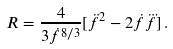Convert formula to latex. <formula><loc_0><loc_0><loc_500><loc_500>R = \frac { 4 } { 3 \dot { f } ^ { 8 / 3 } } [ \ddot { f } ^ { 2 } - 2 \dot { f } \dddot { f } ] \, .</formula> 